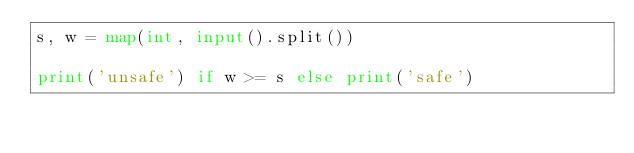Convert code to text. <code><loc_0><loc_0><loc_500><loc_500><_Python_>s, w = map(int, input().split())

print('unsafe') if w >= s else print('safe')</code> 